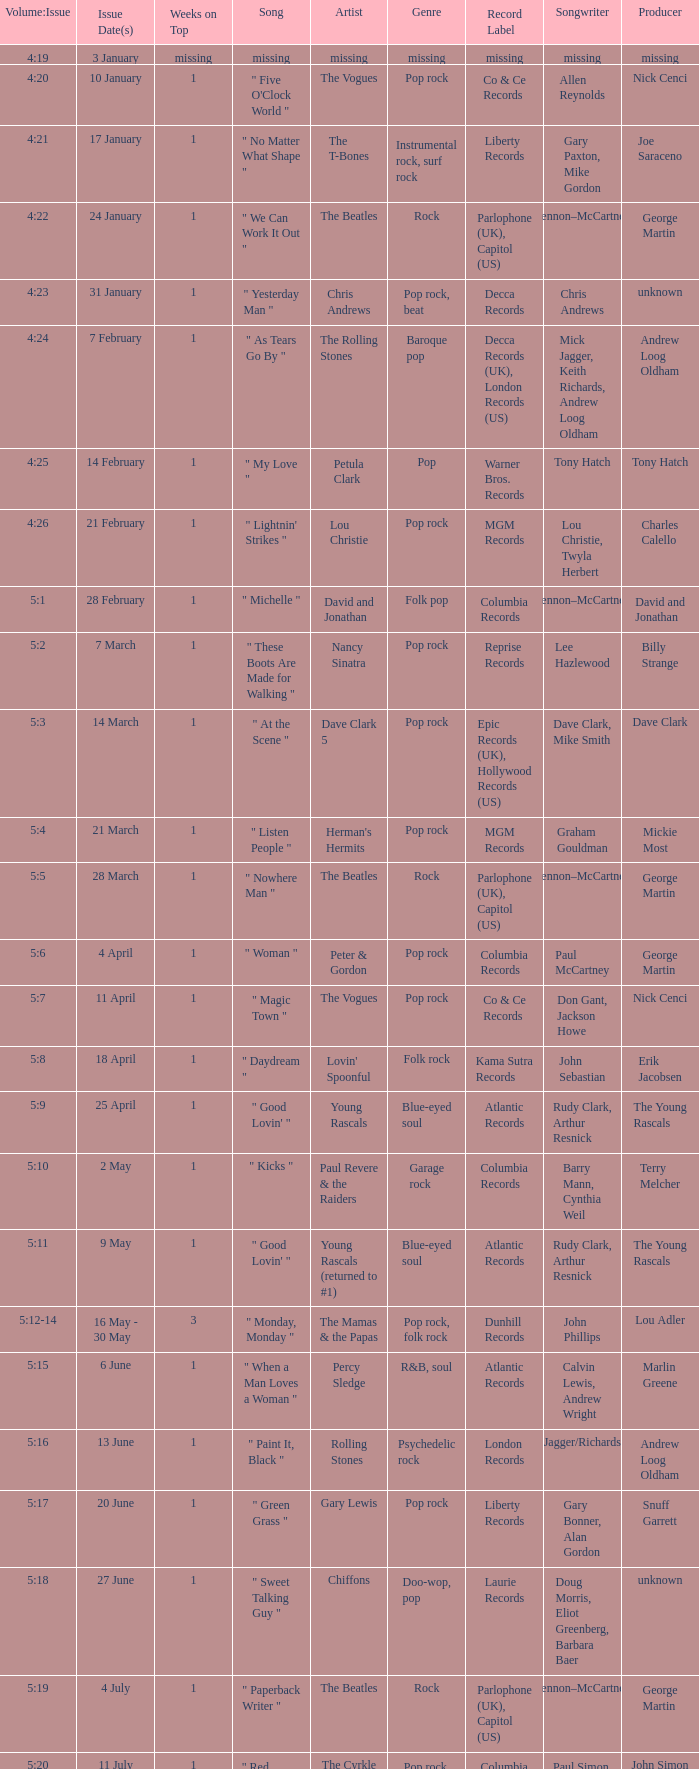Volume:Issue of 5:16 has what song listed? " Paint It, Black ". 